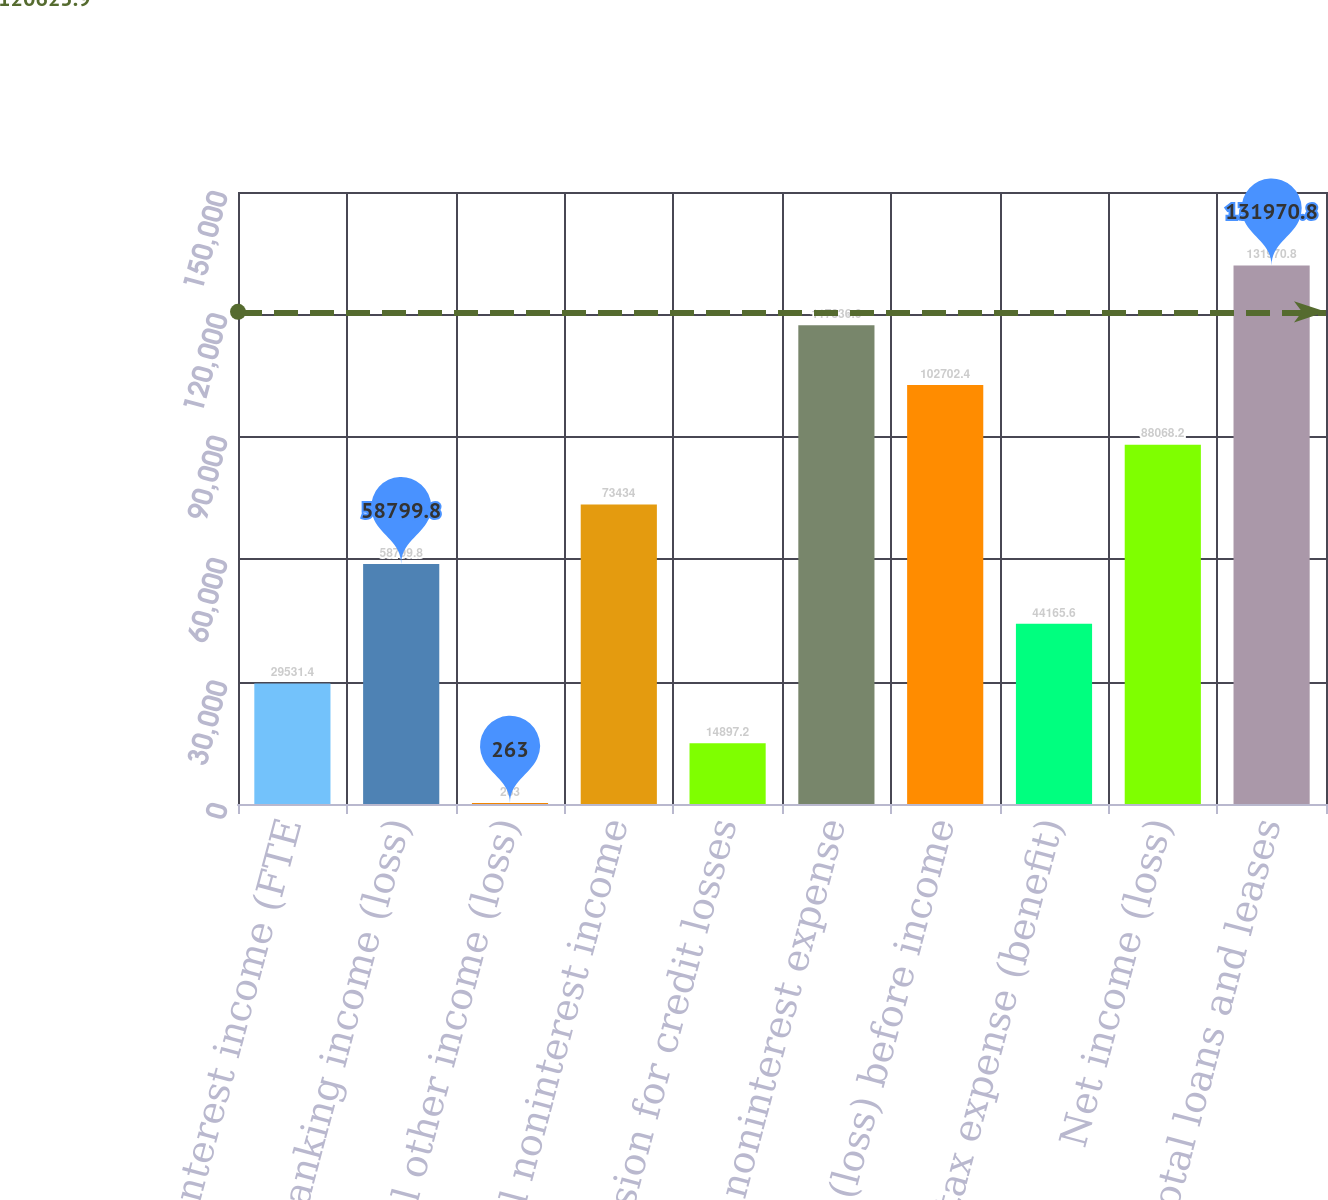Convert chart to OTSL. <chart><loc_0><loc_0><loc_500><loc_500><bar_chart><fcel>Net interest income (FTE<fcel>Mortgage banking income (loss)<fcel>All other income (loss)<fcel>Total noninterest income<fcel>Provision for credit losses<fcel>All other noninterest expense<fcel>Income (loss) before income<fcel>Income tax expense (benefit)<fcel>Net income (loss)<fcel>Total loans and leases<nl><fcel>29531.4<fcel>58799.8<fcel>263<fcel>73434<fcel>14897.2<fcel>117337<fcel>102702<fcel>44165.6<fcel>88068.2<fcel>131971<nl></chart> 